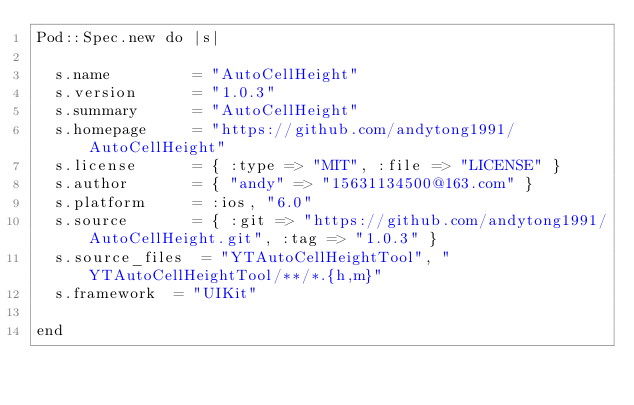<code> <loc_0><loc_0><loc_500><loc_500><_Ruby_>Pod::Spec.new do |s|

  s.name         = "AutoCellHeight"
  s.version      = "1.0.3"
  s.summary      = "AutoCellHeight"
  s.homepage     = "https://github.com/andytong1991/AutoCellHeight"
  s.license      = { :type => "MIT", :file => "LICENSE" }
  s.author       = { "andy" => "15631134500@163.com" }
  s.platform     = :ios, "6.0"
  s.source       = { :git => "https://github.com/andytong1991/AutoCellHeight.git", :tag => "1.0.3" }
  s.source_files  = "YTAutoCellHeightTool", "YTAutoCellHeightTool/**/*.{h,m}"
  s.framework  = "UIKit"
  
end
</code> 